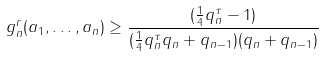<formula> <loc_0><loc_0><loc_500><loc_500>g _ { n } ^ { r } ( a _ { 1 } , \dots , a _ { n } ) \geq \frac { ( \frac { 1 } { 4 } q _ { n } ^ { \tau } - 1 ) } { ( \frac { 1 } { 4 } q _ { n } ^ { \tau } q _ { n } + q _ { n - 1 } ) ( q _ { n } + q _ { n - 1 } ) }</formula> 